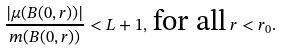Convert formula to latex. <formula><loc_0><loc_0><loc_500><loc_500>\frac { | \mu ( B ( 0 , r ) ) | } { m ( B ( 0 , r ) ) } < L + 1 , \, \text {for all} \, r < r _ { 0 } .</formula> 